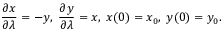<formula> <loc_0><loc_0><loc_500><loc_500>{ \frac { \partial x } { \partial \lambda } } = - y , \, { \frac { \partial y } { \partial \lambda } } = x , \, x ( 0 ) = x _ { 0 } , \, y ( 0 ) = y _ { 0 } .</formula> 